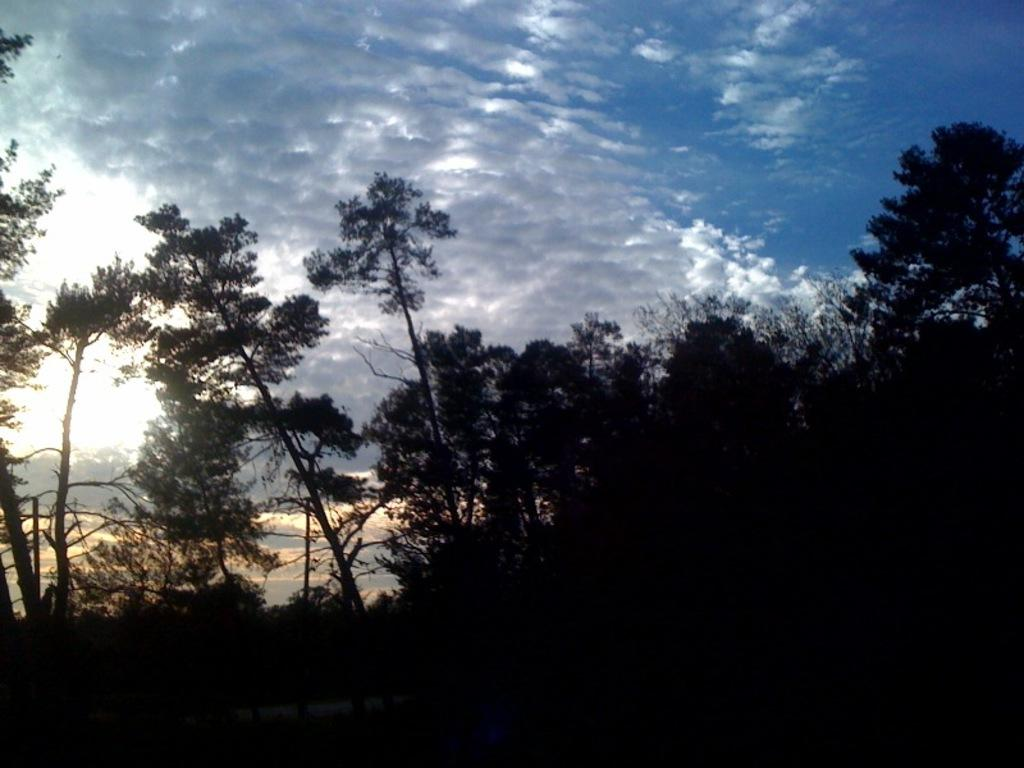What type of vegetation is at the bottom of the image? There are trees at the bottom of the image. What is visible at the top of the image? The sky is visible at the top of the image. Can you describe the sky in the image? The sky appears to be cloudy. Where are the shoes located in the image? There are no shoes present in the image. What type of map can be seen in the image? There is no map present in the image. 